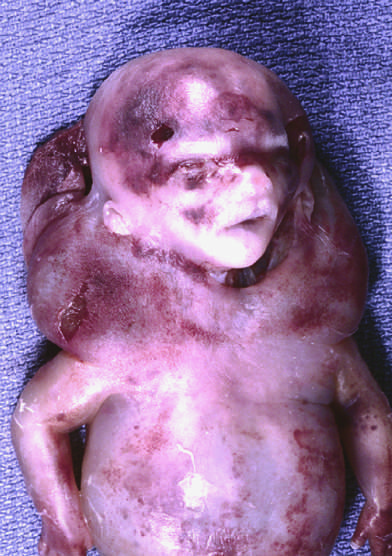what has this condition been termed?
Answer the question using a single word or phrase. Cystic hygroma 